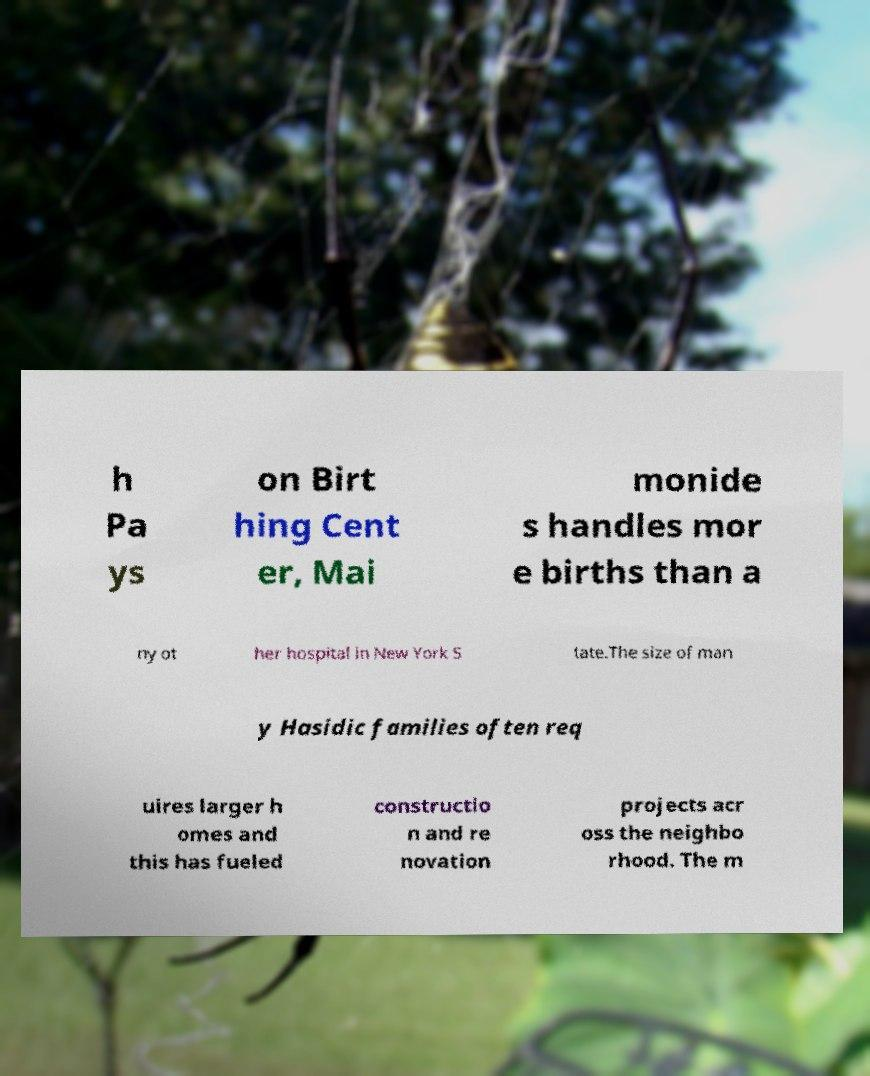Please read and relay the text visible in this image. What does it say? h Pa ys on Birt hing Cent er, Mai monide s handles mor e births than a ny ot her hospital in New York S tate.The size of man y Hasidic families often req uires larger h omes and this has fueled constructio n and re novation projects acr oss the neighbo rhood. The m 